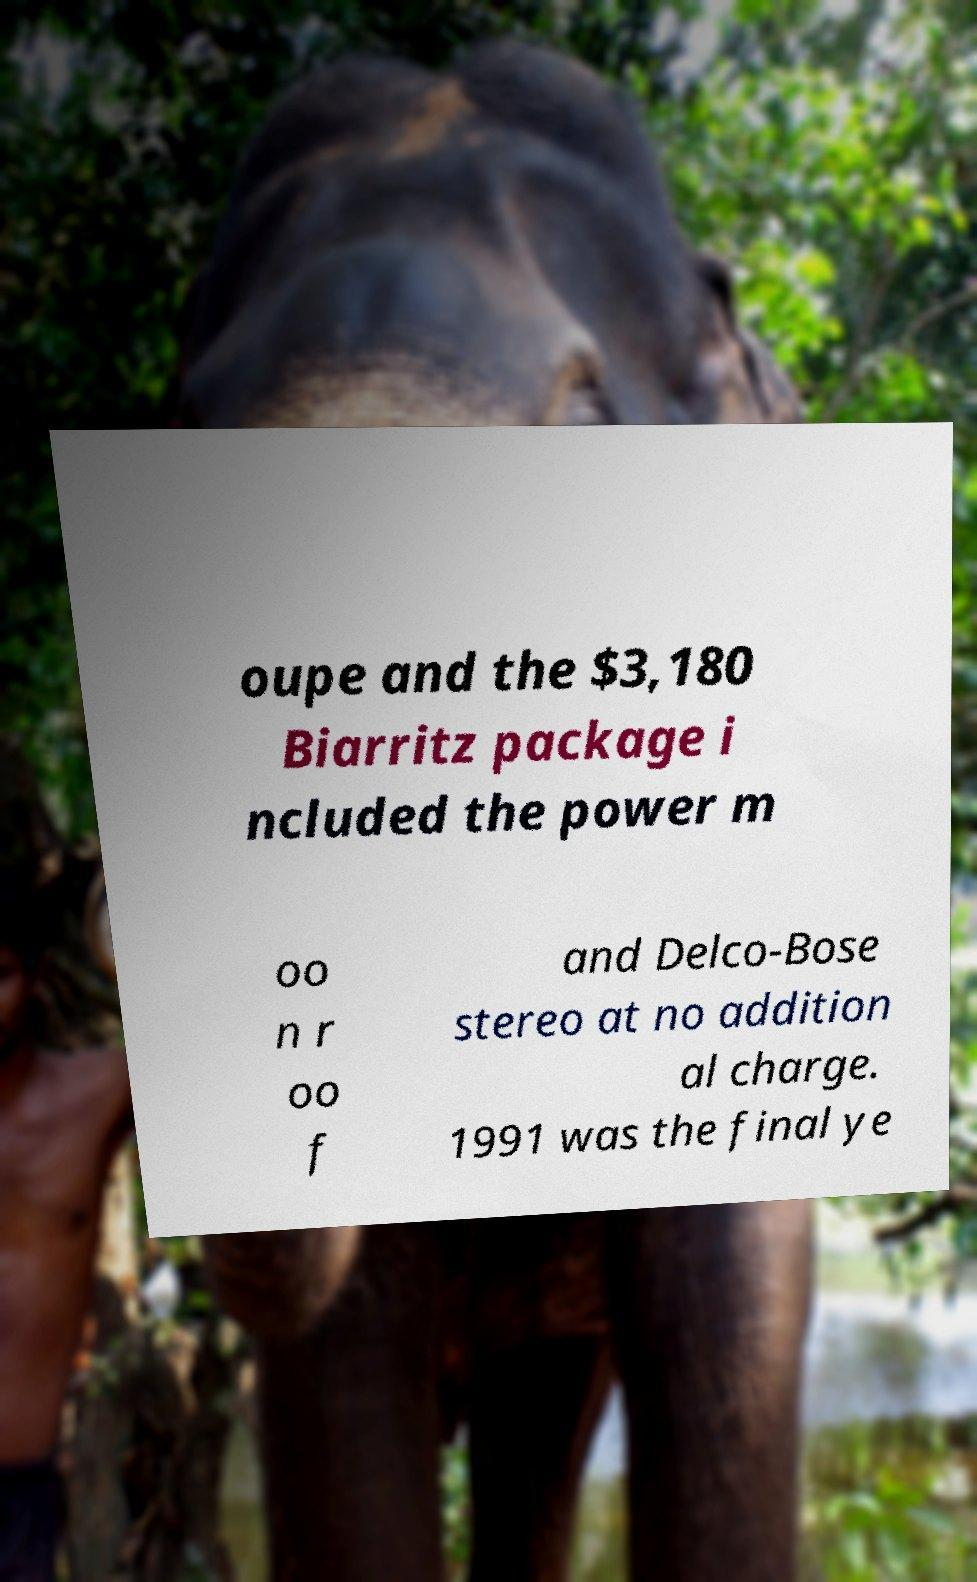For documentation purposes, I need the text within this image transcribed. Could you provide that? oupe and the $3,180 Biarritz package i ncluded the power m oo n r oo f and Delco-Bose stereo at no addition al charge. 1991 was the final ye 